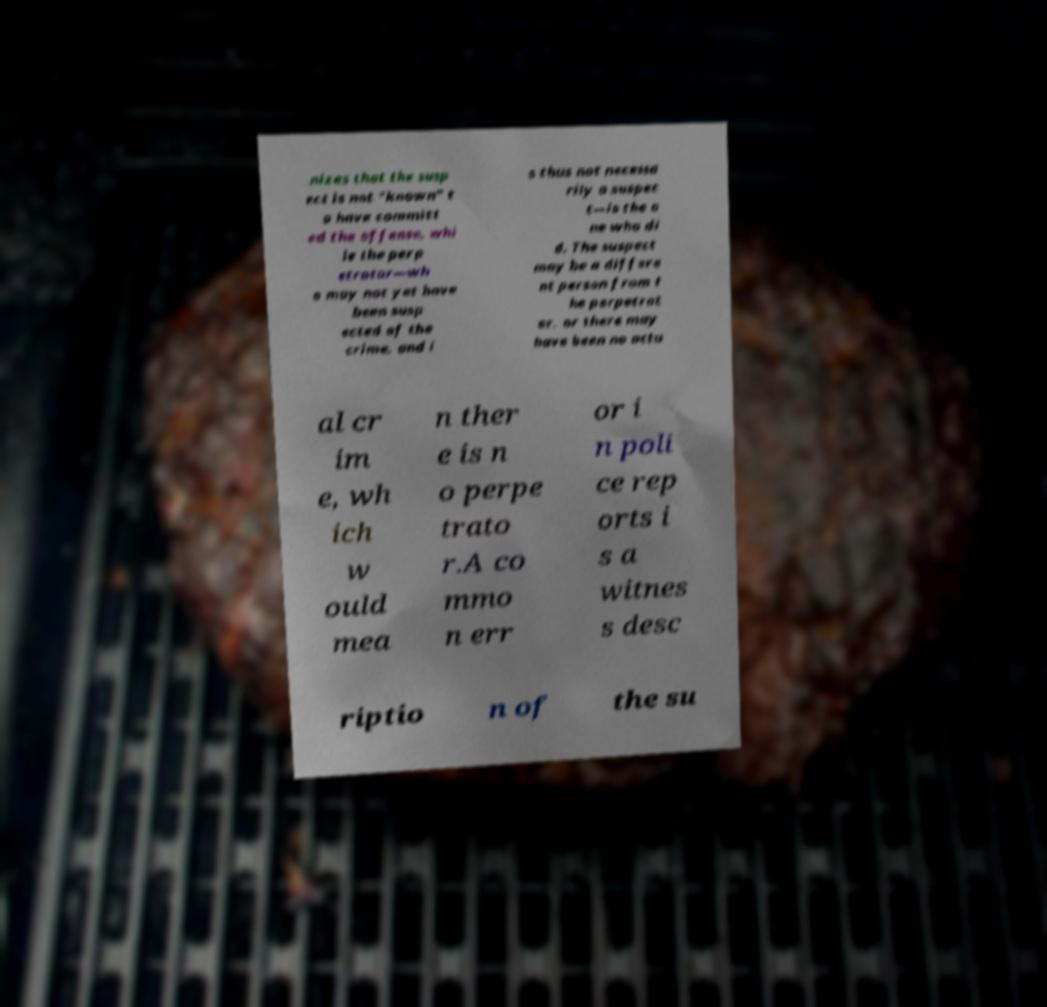Please identify and transcribe the text found in this image. nizes that the susp ect is not "known" t o have committ ed the offense, whi le the perp etrator—wh o may not yet have been susp ected of the crime, and i s thus not necessa rily a suspec t—is the o ne who di d. The suspect may be a differe nt person from t he perpetrat or, or there may have been no actu al cr im e, wh ich w ould mea n ther e is n o perpe trato r.A co mmo n err or i n poli ce rep orts i s a witnes s desc riptio n of the su 